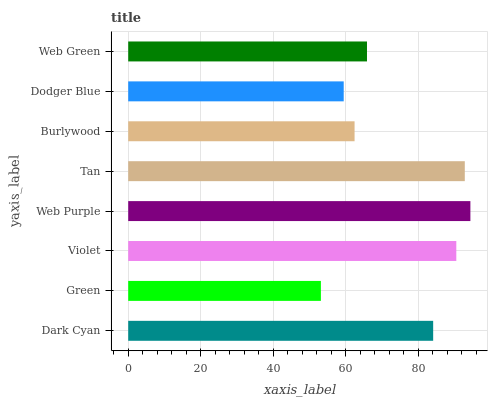Is Green the minimum?
Answer yes or no. Yes. Is Web Purple the maximum?
Answer yes or no. Yes. Is Violet the minimum?
Answer yes or no. No. Is Violet the maximum?
Answer yes or no. No. Is Violet greater than Green?
Answer yes or no. Yes. Is Green less than Violet?
Answer yes or no. Yes. Is Green greater than Violet?
Answer yes or no. No. Is Violet less than Green?
Answer yes or no. No. Is Dark Cyan the high median?
Answer yes or no. Yes. Is Web Green the low median?
Answer yes or no. Yes. Is Web Purple the high median?
Answer yes or no. No. Is Web Purple the low median?
Answer yes or no. No. 